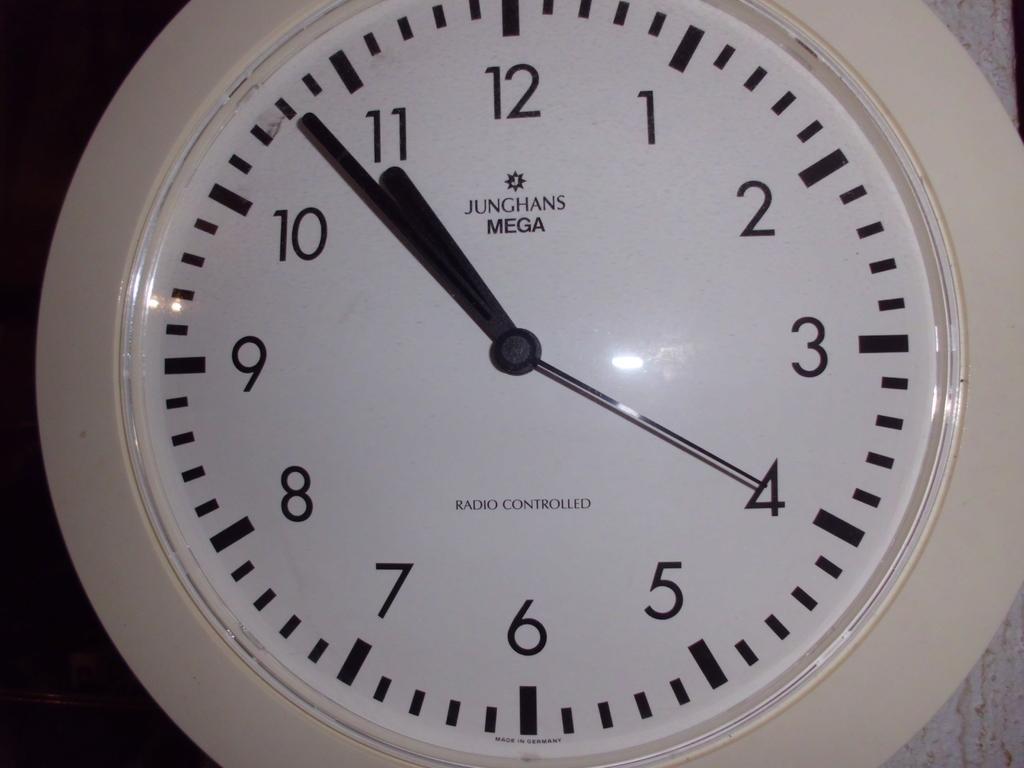<image>
Summarize the visual content of the image. A Junghans Mega white clock that is Radio Controlled. 